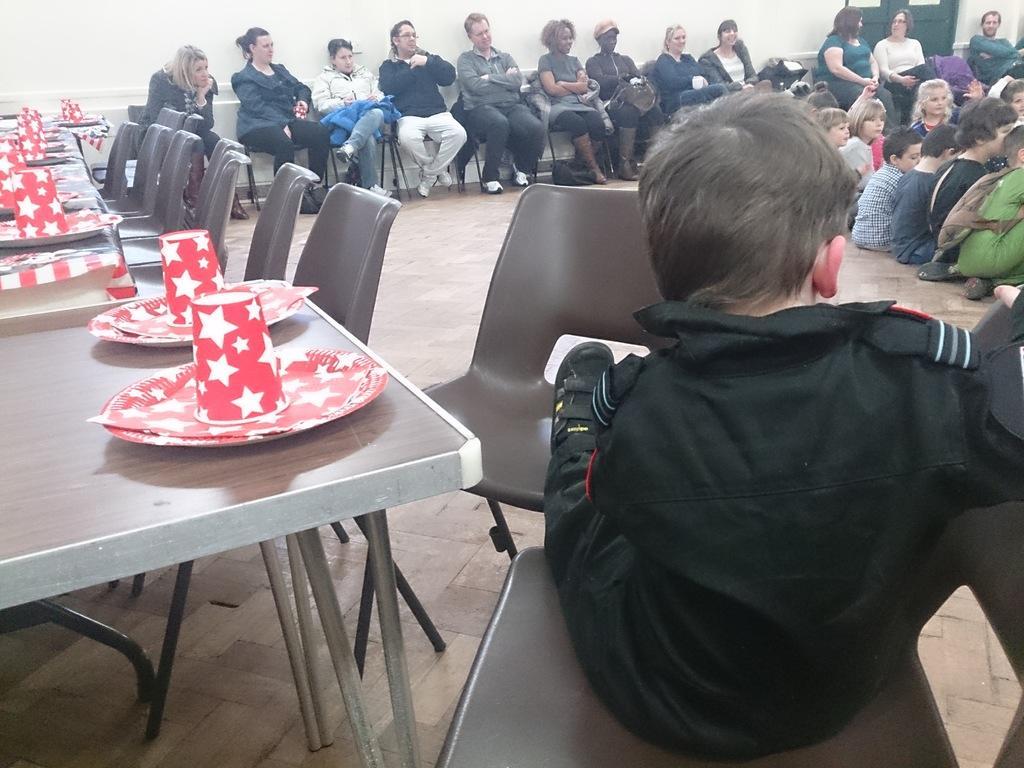How would you summarize this image in a sentence or two? In the image there are many adults sat on chairs and there are kids sat on floor. There are tables with plates and glasses on left side corner and there are chairs in front of it. There is a boy with black jacket sat on chair in the right side corner front of the image. 